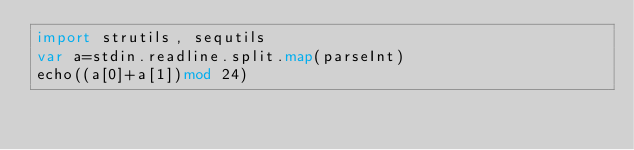Convert code to text. <code><loc_0><loc_0><loc_500><loc_500><_Nim_>import strutils, sequtils
var a=stdin.readline.split.map(parseInt)
echo((a[0]+a[1])mod 24)</code> 